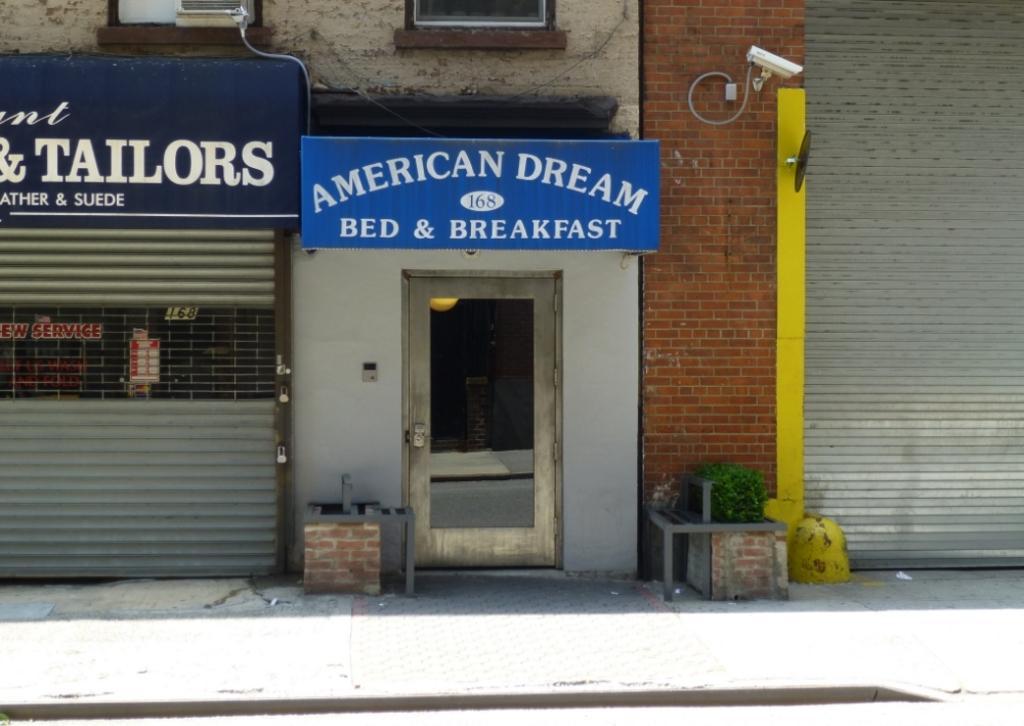In one or two sentences, can you explain what this image depicts? In this image I can see on the left side there is the shutter, in the middle it is the store. There is a cc camera on this wall, at the bottom there is the plant. 